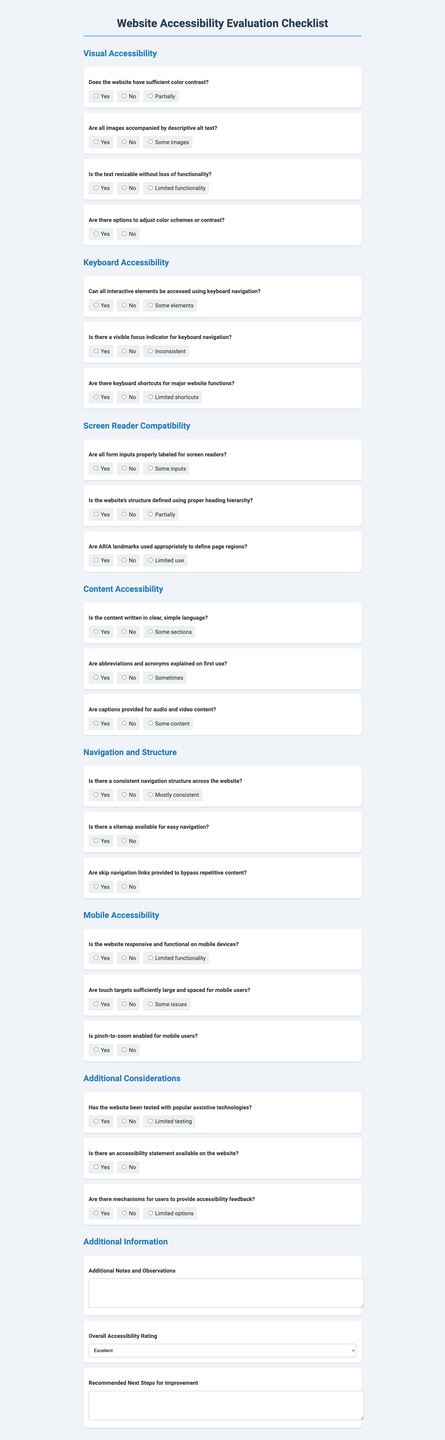what is the title of the form? The title of the form is located at the top of the document under the main heading.
Answer: Website Accessibility Evaluation Checklist how many sections are there in the form? The number of sections can be determined by counting the sections listed in the document.
Answer: 7 what is one of the questions under Visual Accessibility? This question can be found in the Visual Accessibility section and asks about color contrast.
Answer: Does the website have sufficient color contrast? what option is available for overall accessibility rating? The options provided for overall accessibility rating are listed in a dropdown menu.
Answer: Excellent is there a question about keyboard navigation in the form? The form includes questions specifically about keyboard navigation under the Keyboard Accessibility section.
Answer: Yes which section contains questions about mobile accessibility? This section will specifically address mobile-related features and accessibility considerations in the document.
Answer: Mobile Accessibility are there recommendations for next steps in the evaluation? The form includes a section for users to fill out regarding next steps for improvement.
Answer: Yes 